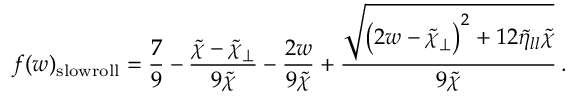<formula> <loc_0><loc_0><loc_500><loc_500>f ( w ) _ { s l o w r o l l } = \frac { 7 } { 9 } - \frac { \tilde { \chi } - \tilde { \chi } _ { \perp } } { 9 \tilde { \chi } } - \frac { 2 w } { 9 \tilde { \chi } } + \frac { \sqrt { \left ( 2 w - \tilde { \chi } _ { \perp } \right ) ^ { 2 } + 1 2 \tilde { \eta } _ { l l } \tilde { \chi } } } { 9 \tilde { \chi } } \, .</formula> 